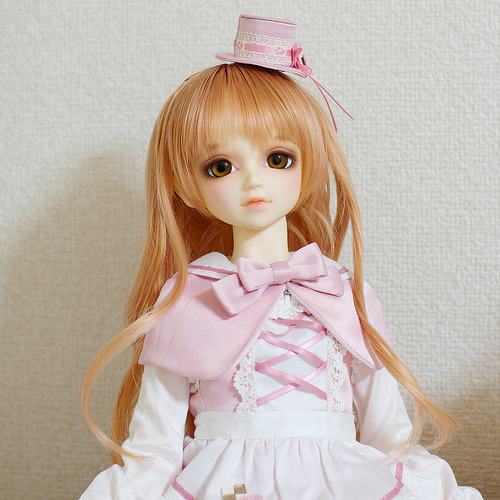<image>
Is there a hat on the wall? No. The hat is not positioned on the wall. They may be near each other, but the hat is not supported by or resting on top of the wall. 